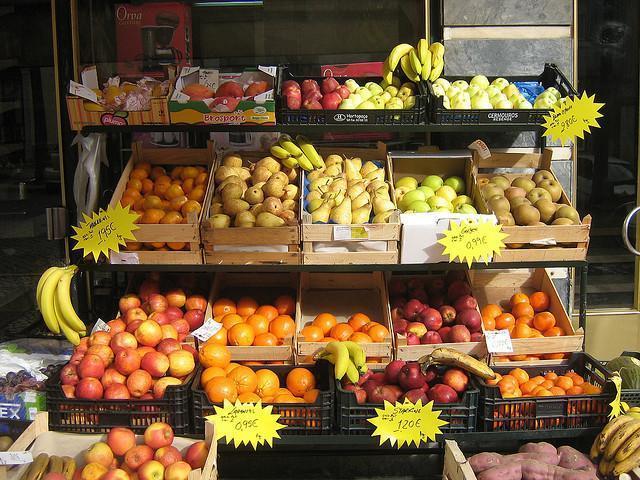How many apples are there?
Give a very brief answer. 4. How many oranges are there?
Give a very brief answer. 3. 